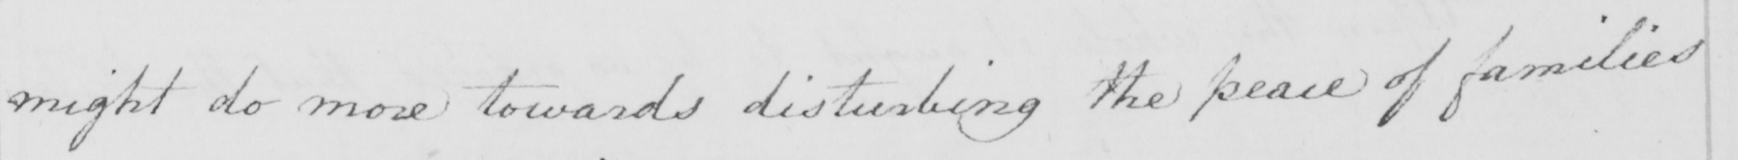Can you tell me what this handwritten text says? might do more towards disturbing the peace of families 